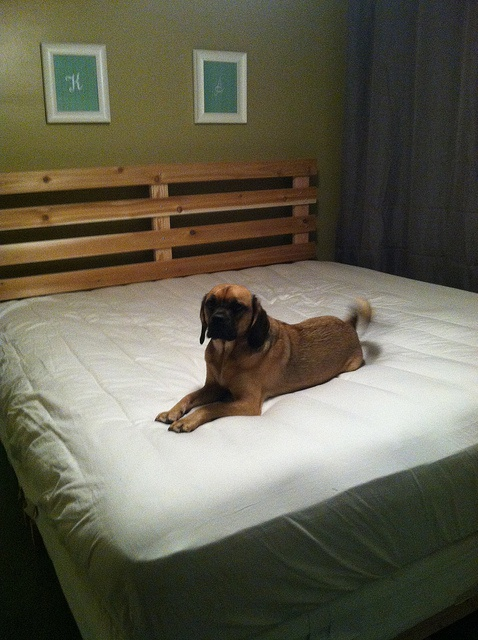Describe the objects in this image and their specific colors. I can see bed in gray, black, lightgray, darkgray, and maroon tones and dog in gray, black, and maroon tones in this image. 